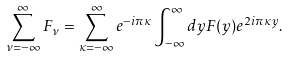<formula> <loc_0><loc_0><loc_500><loc_500>\sum _ { \nu = - \infty } ^ { \infty } F _ { \nu } = \sum _ { \kappa = - \infty } ^ { \infty } e ^ { - i \pi \kappa } \int _ { - \infty } ^ { \infty } d y F ( y ) e ^ { 2 i \pi \kappa y } .</formula> 